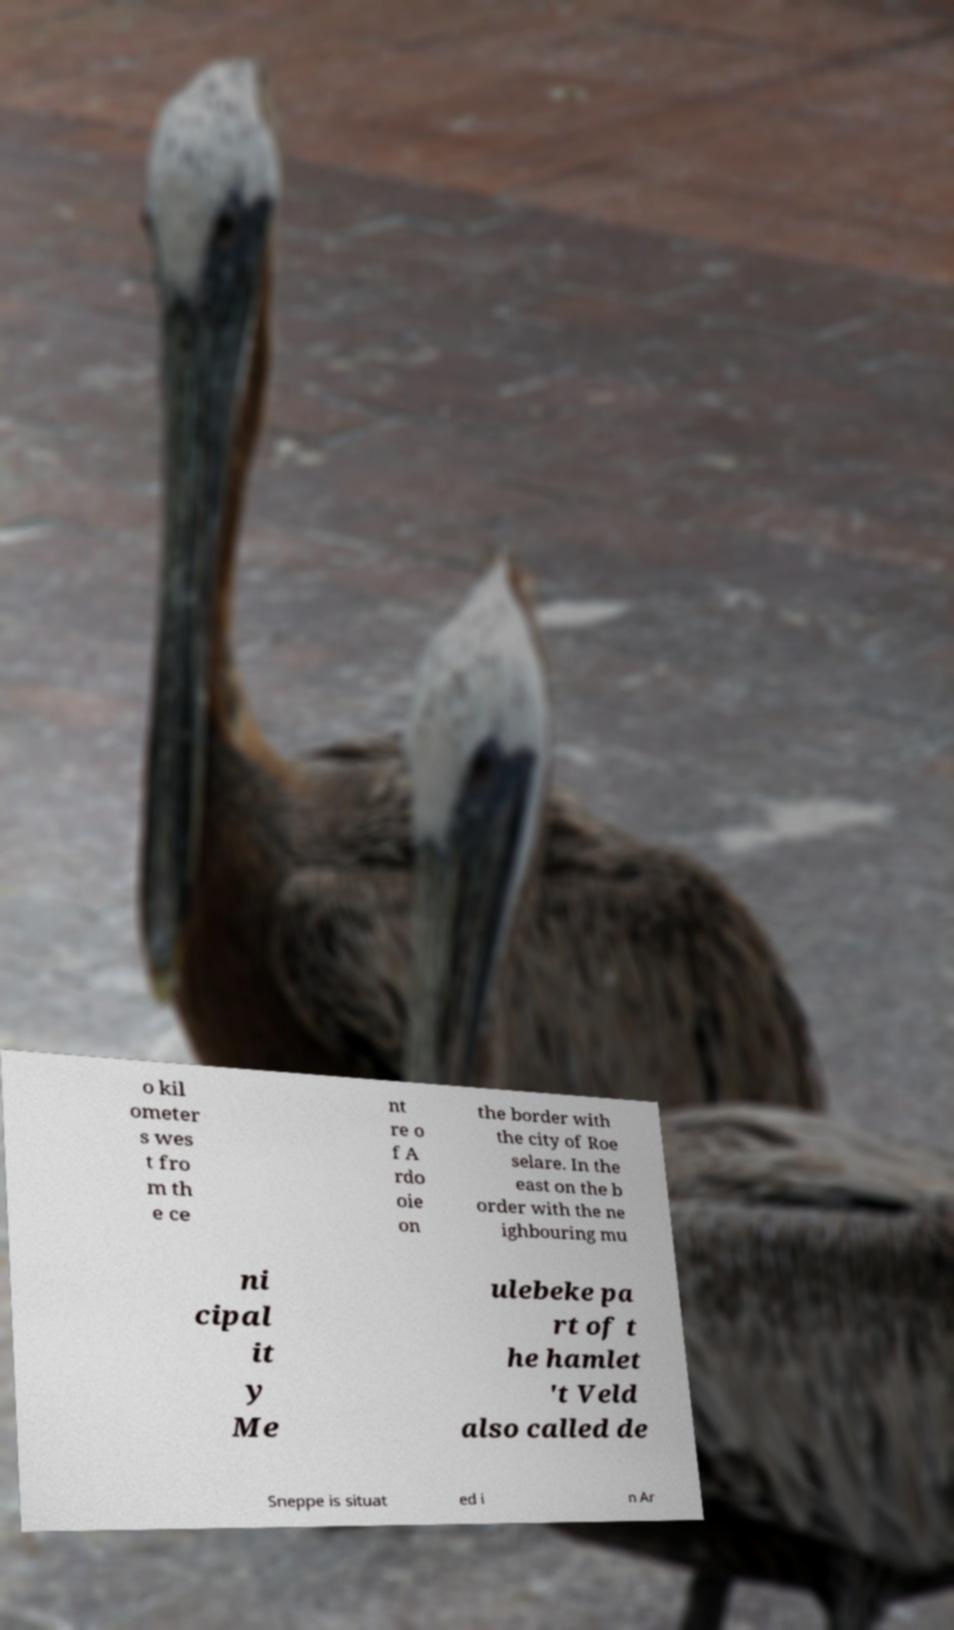For documentation purposes, I need the text within this image transcribed. Could you provide that? o kil ometer s wes t fro m th e ce nt re o f A rdo oie on the border with the city of Roe selare. In the east on the b order with the ne ighbouring mu ni cipal it y Me ulebeke pa rt of t he hamlet 't Veld also called de Sneppe is situat ed i n Ar 